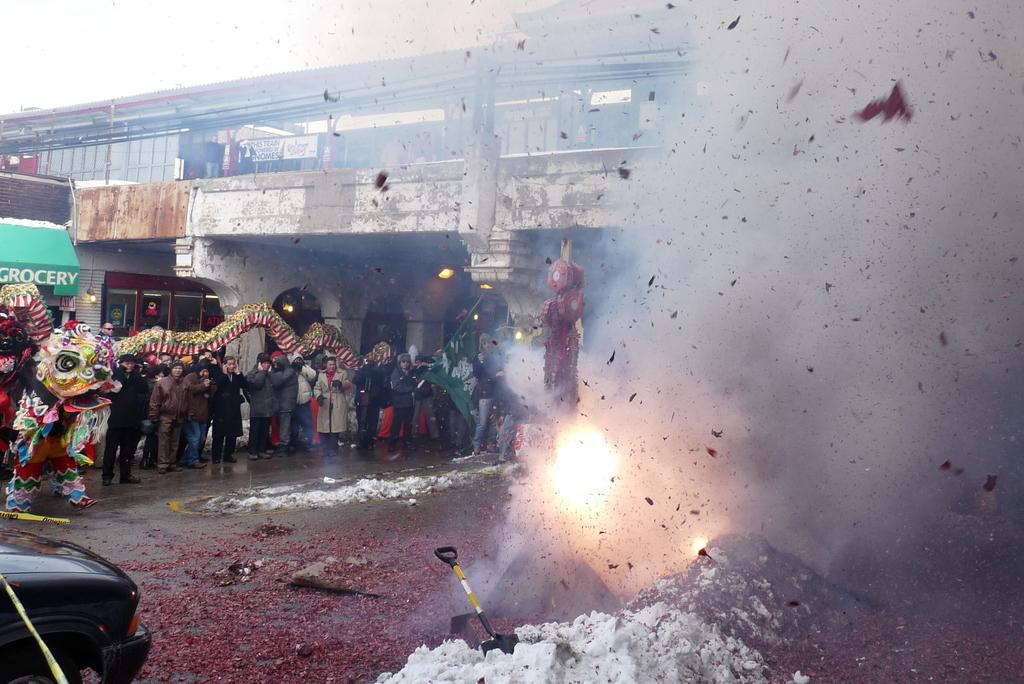What is the main subject of the image? There are people standing with a dragon in the image. What else can be seen in the image besides the people and dragon? There is a car on a road in the image. Are there any food items visible in the image? Yes, there are crackers on the right side of the image. What can be seen in the background of the image? There is a bridge in the background of the image. What type of collar is the dragon wearing in the image? The dragon is not wearing a collar in the image, as dragons do not typically wear collars. 